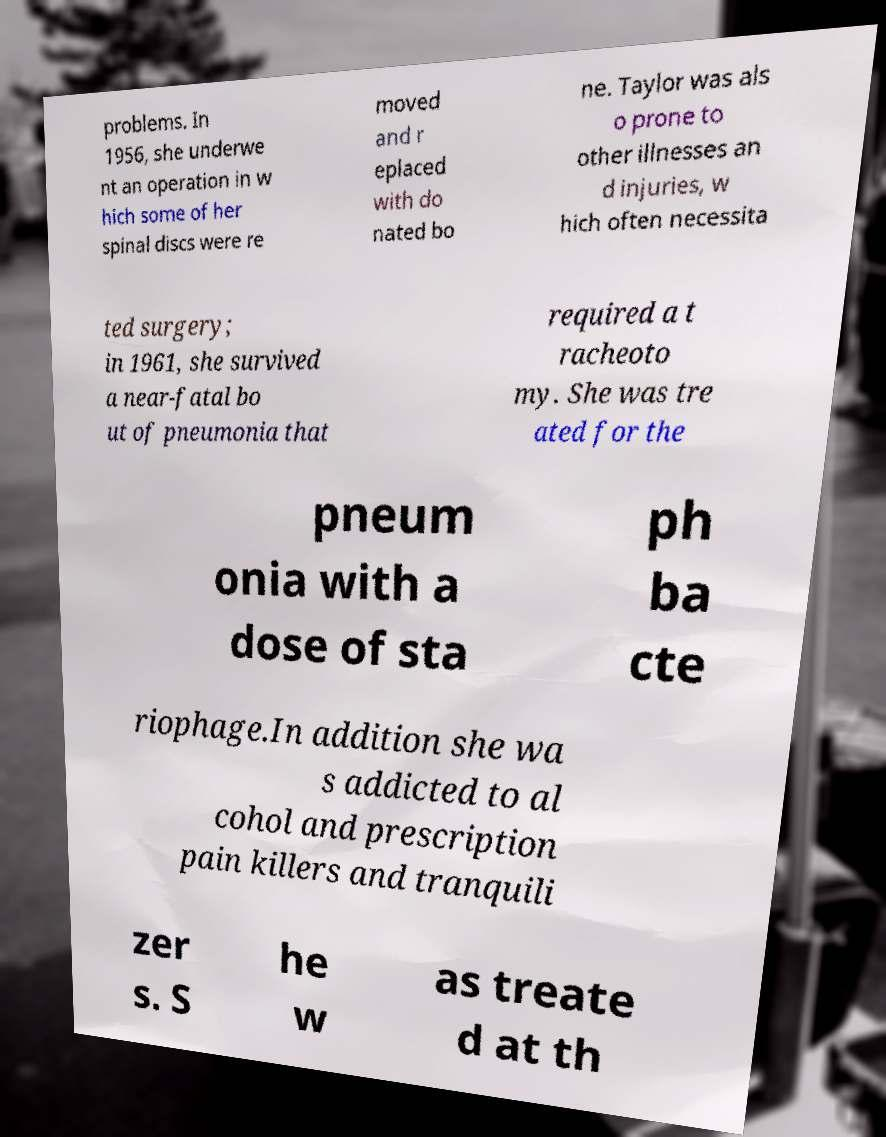Can you accurately transcribe the text from the provided image for me? problems. In 1956, she underwe nt an operation in w hich some of her spinal discs were re moved and r eplaced with do nated bo ne. Taylor was als o prone to other illnesses an d injuries, w hich often necessita ted surgery; in 1961, she survived a near-fatal bo ut of pneumonia that required a t racheoto my. She was tre ated for the pneum onia with a dose of sta ph ba cte riophage.In addition she wa s addicted to al cohol and prescription pain killers and tranquili zer s. S he w as treate d at th 